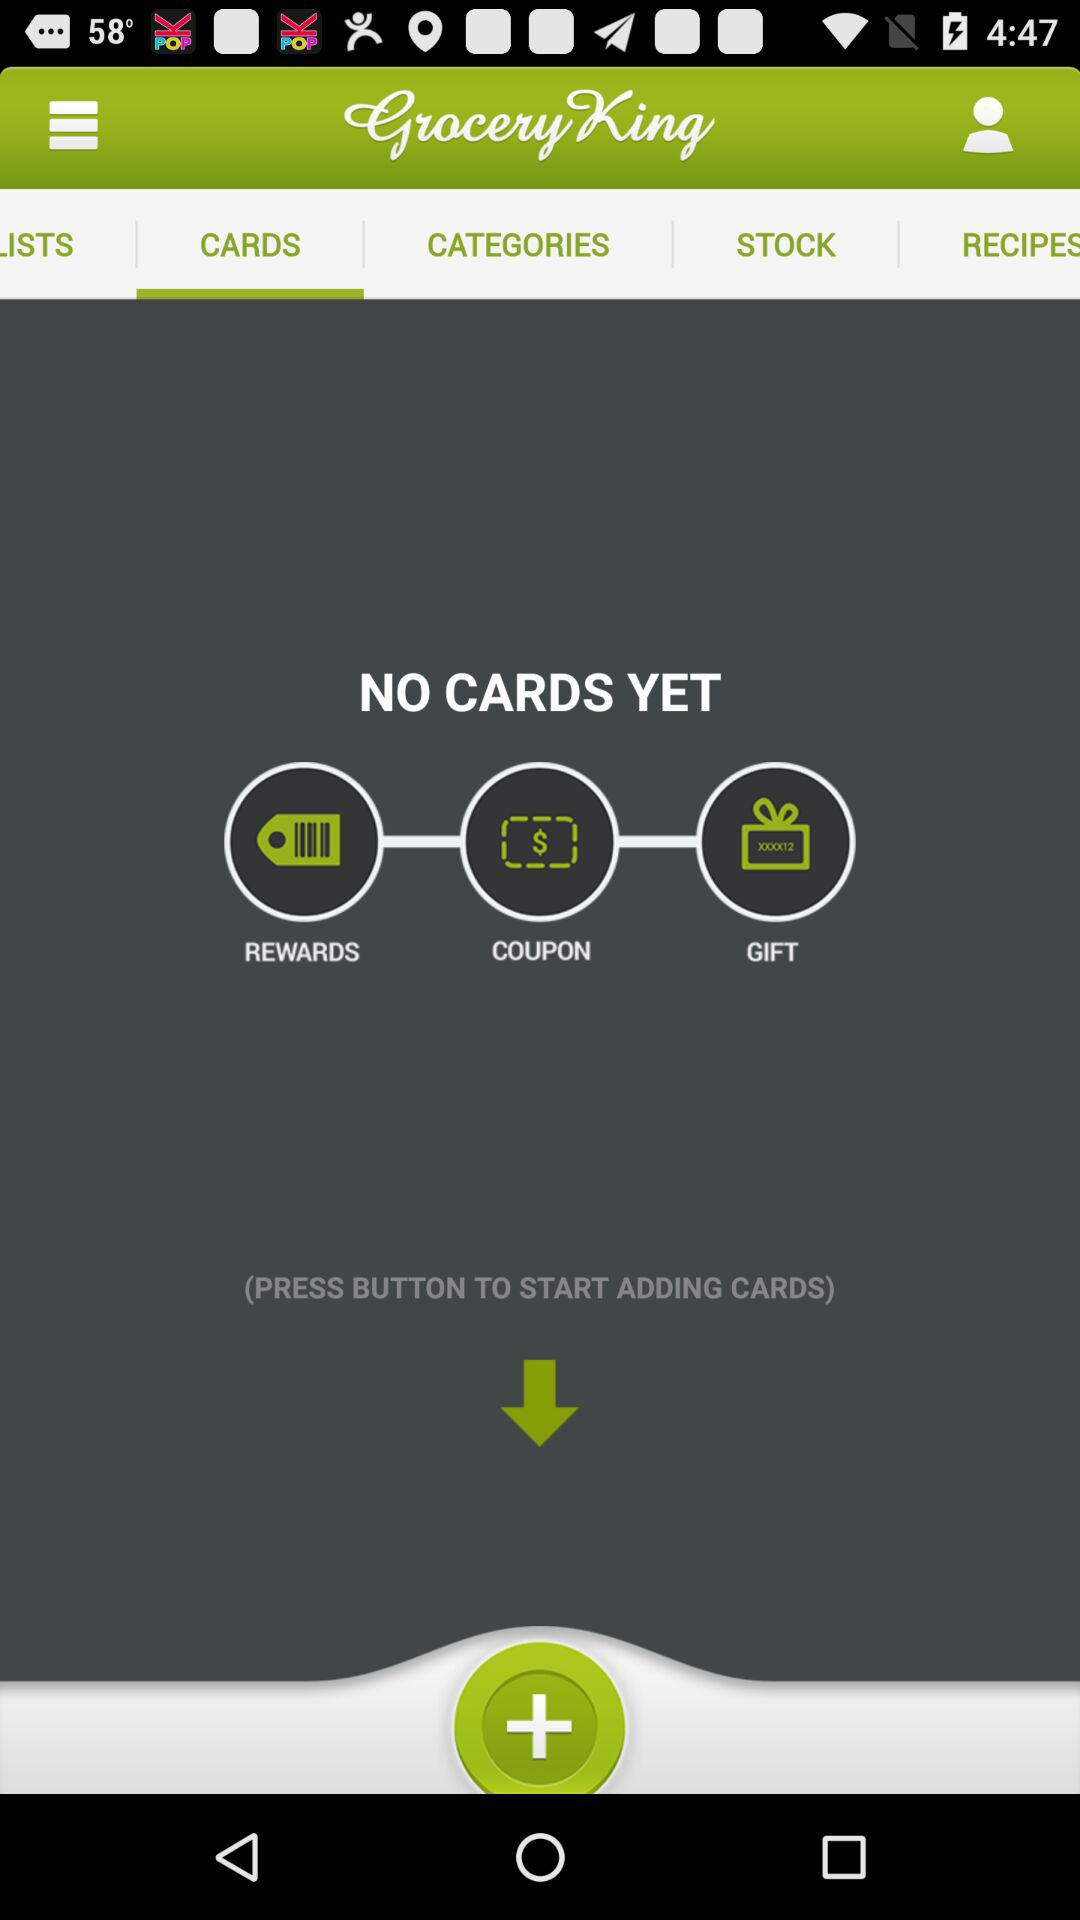What is the selected tab? The selected tab is "CARDS". 